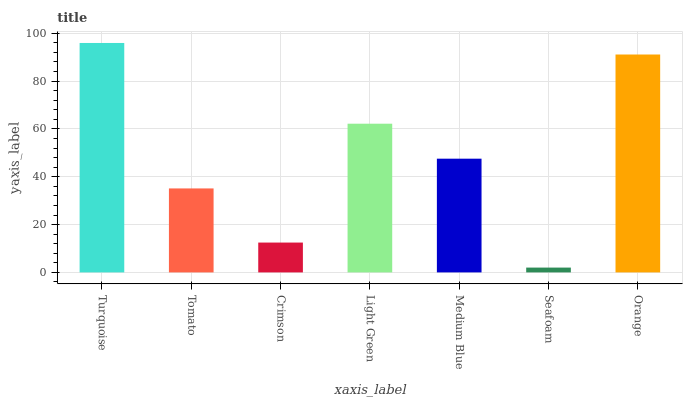Is Seafoam the minimum?
Answer yes or no. Yes. Is Turquoise the maximum?
Answer yes or no. Yes. Is Tomato the minimum?
Answer yes or no. No. Is Tomato the maximum?
Answer yes or no. No. Is Turquoise greater than Tomato?
Answer yes or no. Yes. Is Tomato less than Turquoise?
Answer yes or no. Yes. Is Tomato greater than Turquoise?
Answer yes or no. No. Is Turquoise less than Tomato?
Answer yes or no. No. Is Medium Blue the high median?
Answer yes or no. Yes. Is Medium Blue the low median?
Answer yes or no. Yes. Is Turquoise the high median?
Answer yes or no. No. Is Orange the low median?
Answer yes or no. No. 